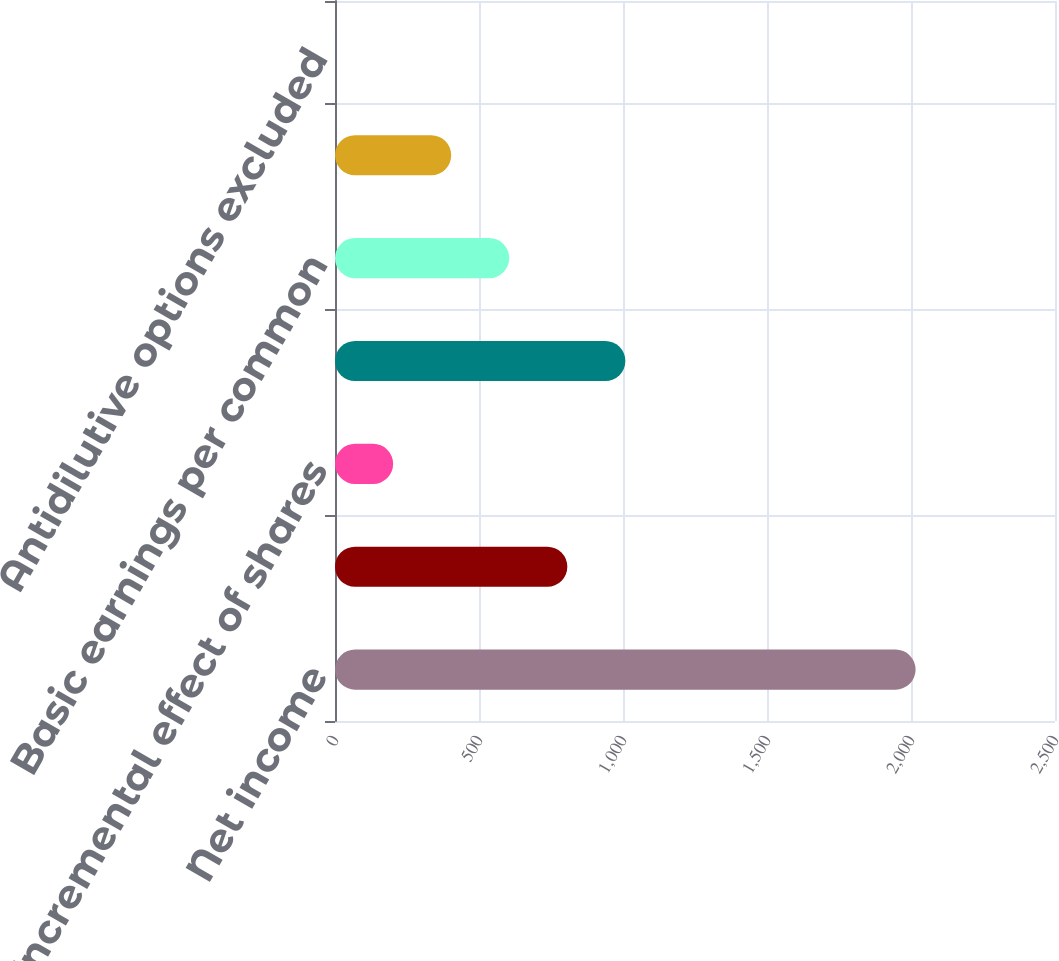Convert chart. <chart><loc_0><loc_0><loc_500><loc_500><bar_chart><fcel>Net income<fcel>Weighted-average shares of<fcel>Incremental effect of shares<fcel>Weighted-average common and<fcel>Basic earnings per common<fcel>Diluted earnings per common<fcel>Antidilutive options excluded<nl><fcel>2016<fcel>806.64<fcel>201.96<fcel>1008.2<fcel>605.08<fcel>403.52<fcel>0.4<nl></chart> 